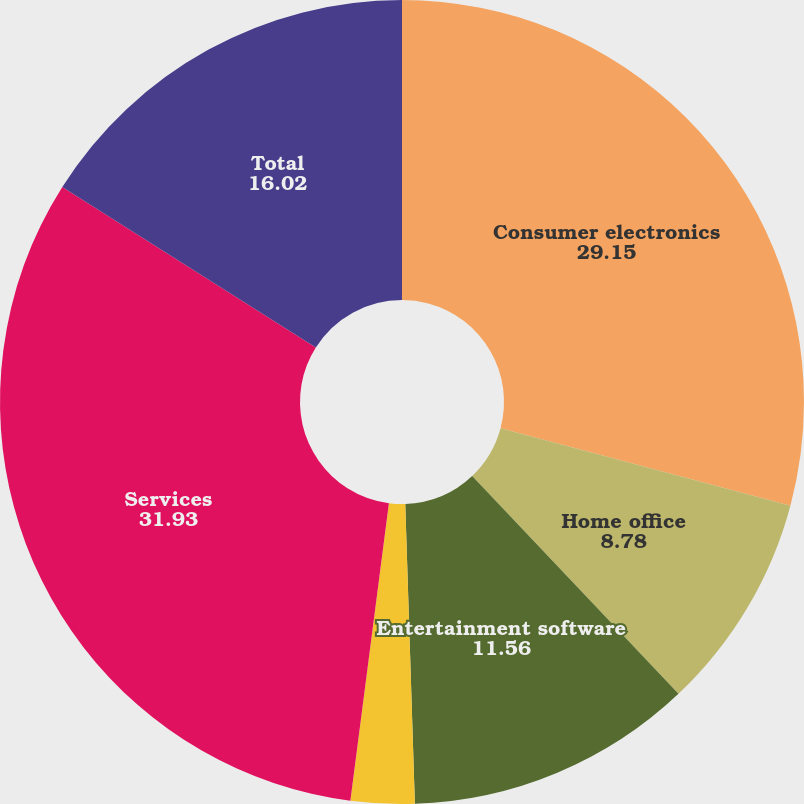Convert chart. <chart><loc_0><loc_0><loc_500><loc_500><pie_chart><fcel>Consumer electronics<fcel>Home office<fcel>Entertainment software<fcel>Appliances<fcel>Services<fcel>Total<nl><fcel>29.15%<fcel>8.78%<fcel>11.56%<fcel>2.56%<fcel>31.93%<fcel>16.02%<nl></chart> 